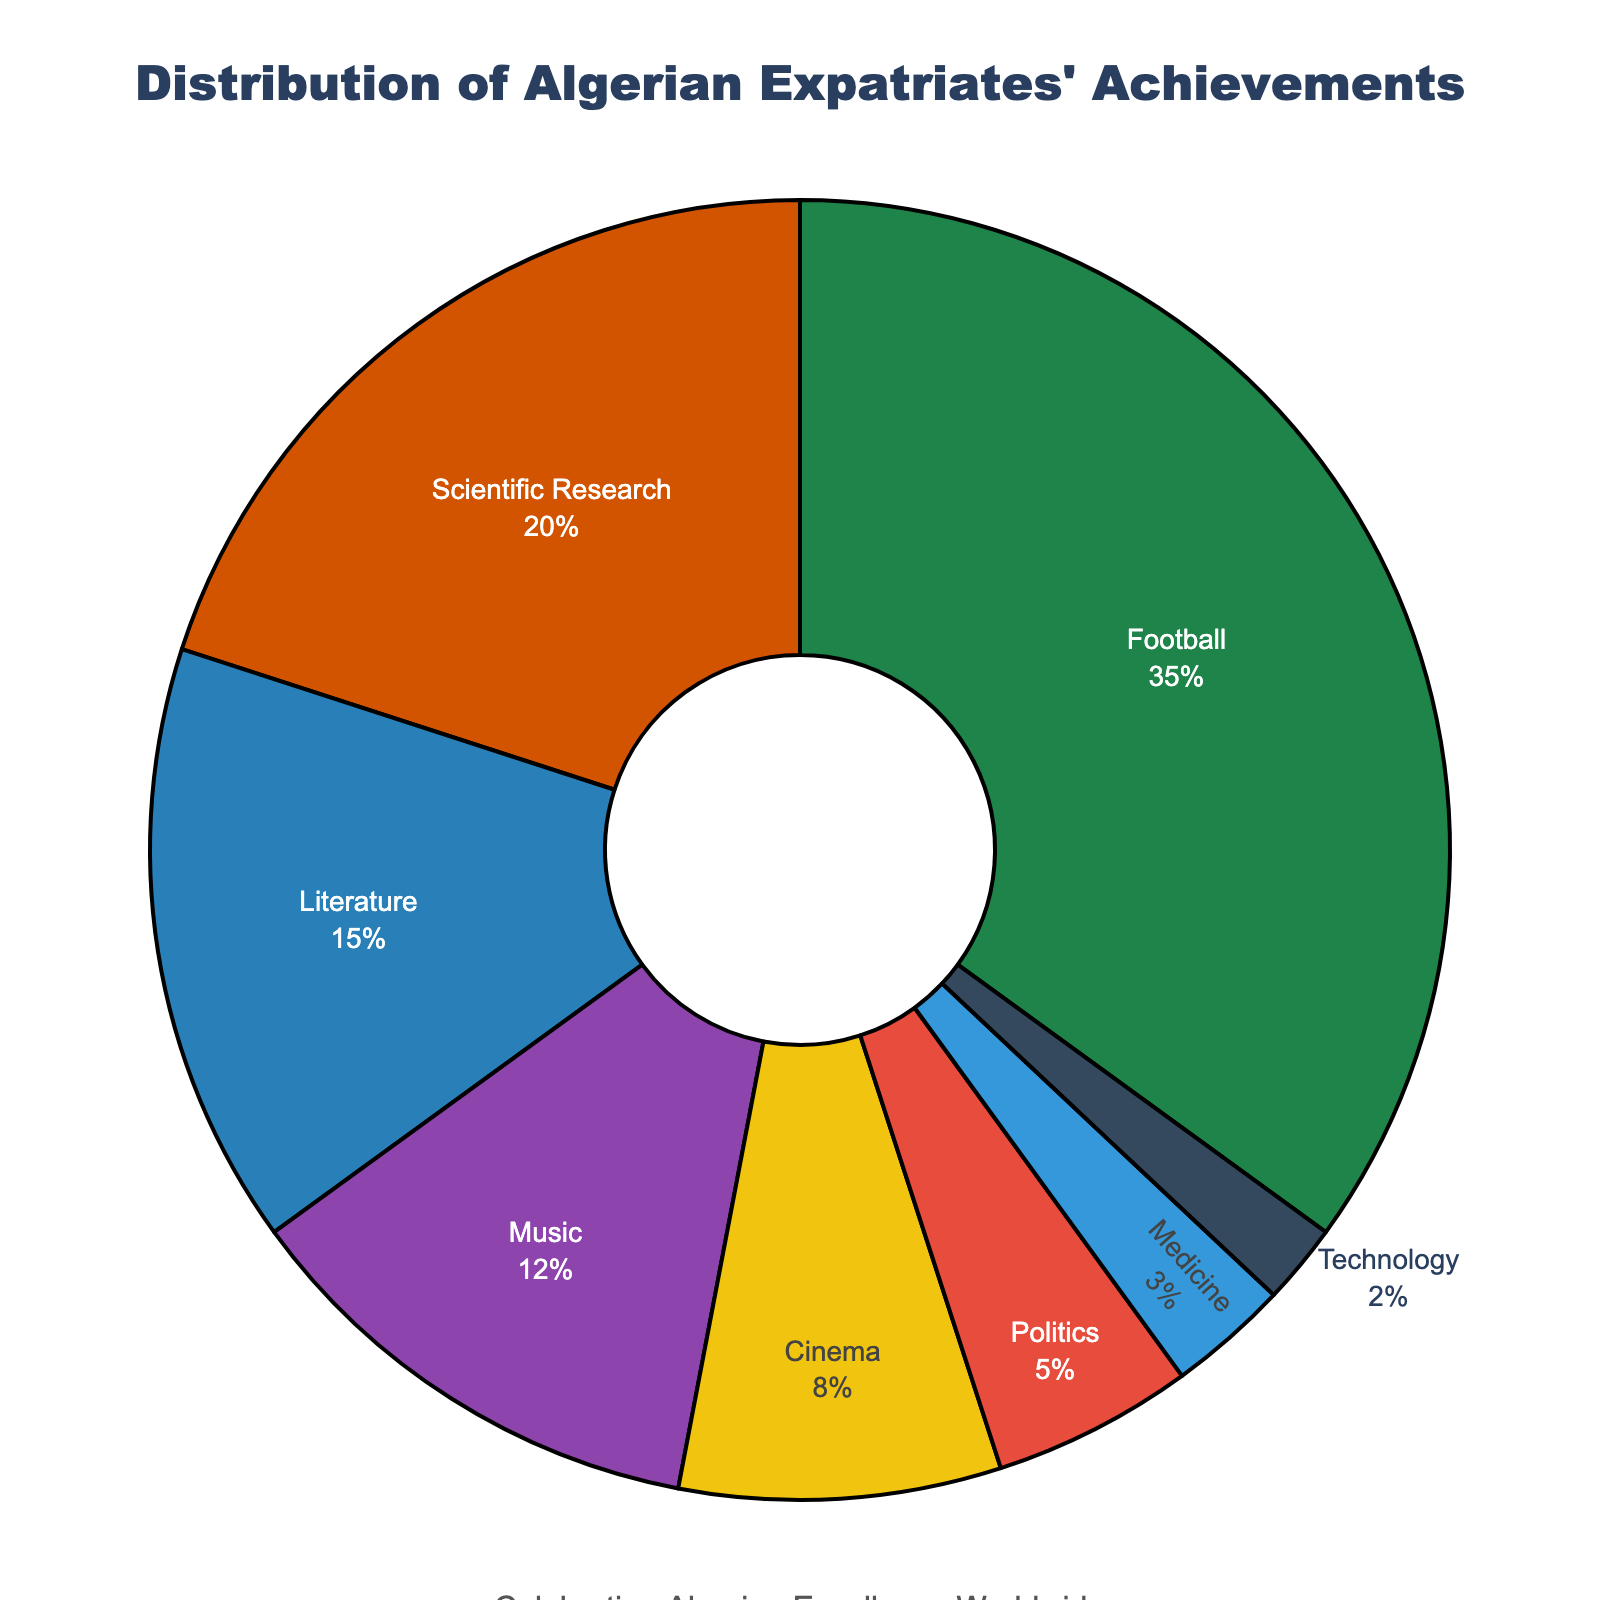What's the largest category in the pie chart? The largest category can be identified by looking at the segment that occupies the most space in the pie chart. The one representing "Football" is visibly the largest.
Answer: Football Which field contributes to international recognition the least? The smallest slice of the pie chart represents the field with the least contribution. In this pie chart, "Technology" has the smallest slice.
Answer: Technology How many more percentage points does Football have compared to Scientific Research? To find out how many more percentage points Football has than Scientific Research, subtract the percentage for Scientific Research from the percentage for Football (35% - 20% = 15%).
Answer: 15% What is the combined percentage for Literature, Music, and Cinema? To find the combined percentage, add the percentages of Literature, Music, and Cinema (15% + 12% + 8% = 35%).
Answer: 35% Which field comes second in terms of percentage contribution? The second largest segment should be identified. After Football, the next largest segment represents "Scientific Research" at 20%.
Answer: Scientific Research Is the contribution of Medicine greater than that of Politics? Compare the percentage of Medicine (3%) with that of Politics (5%). Medicine has a smaller percentage than Politics.
Answer: No How does the percentage of Music compare to that of Cinema and Medicine combined? We need to add the percentages of Cinema and Medicine, then compare the result with the percentage of Music. Cinema (8%) + Medicine (3%) = 11%, while Music is at 12%. 12% is greater than 11%.
Answer: Music is greater What is the total percentage of fields each contributing less than 10%? Add the percentages of all fields contributing less than 10%. These are Cinema (8%), Politics (5%), Medicine (3%), and Technology (2%), totaling 8% + 5% + 3% + 2% = 18%.
Answer: 18% Identify the field represented by the green color. The color green is assigned to the largest segment of the pie chart, which is "Football" at 35%.
Answer: Football What's the percentage contribution of fields other than Football and Scientific Research? Subtract the combined percentage of Football and Scientific Research from 100% (100% - 35% - 20% = 45%). These percentages belong to the remaining fields: Literature, Music, Cinema, Politics, Medicine, and Technology.
Answer: 45% 